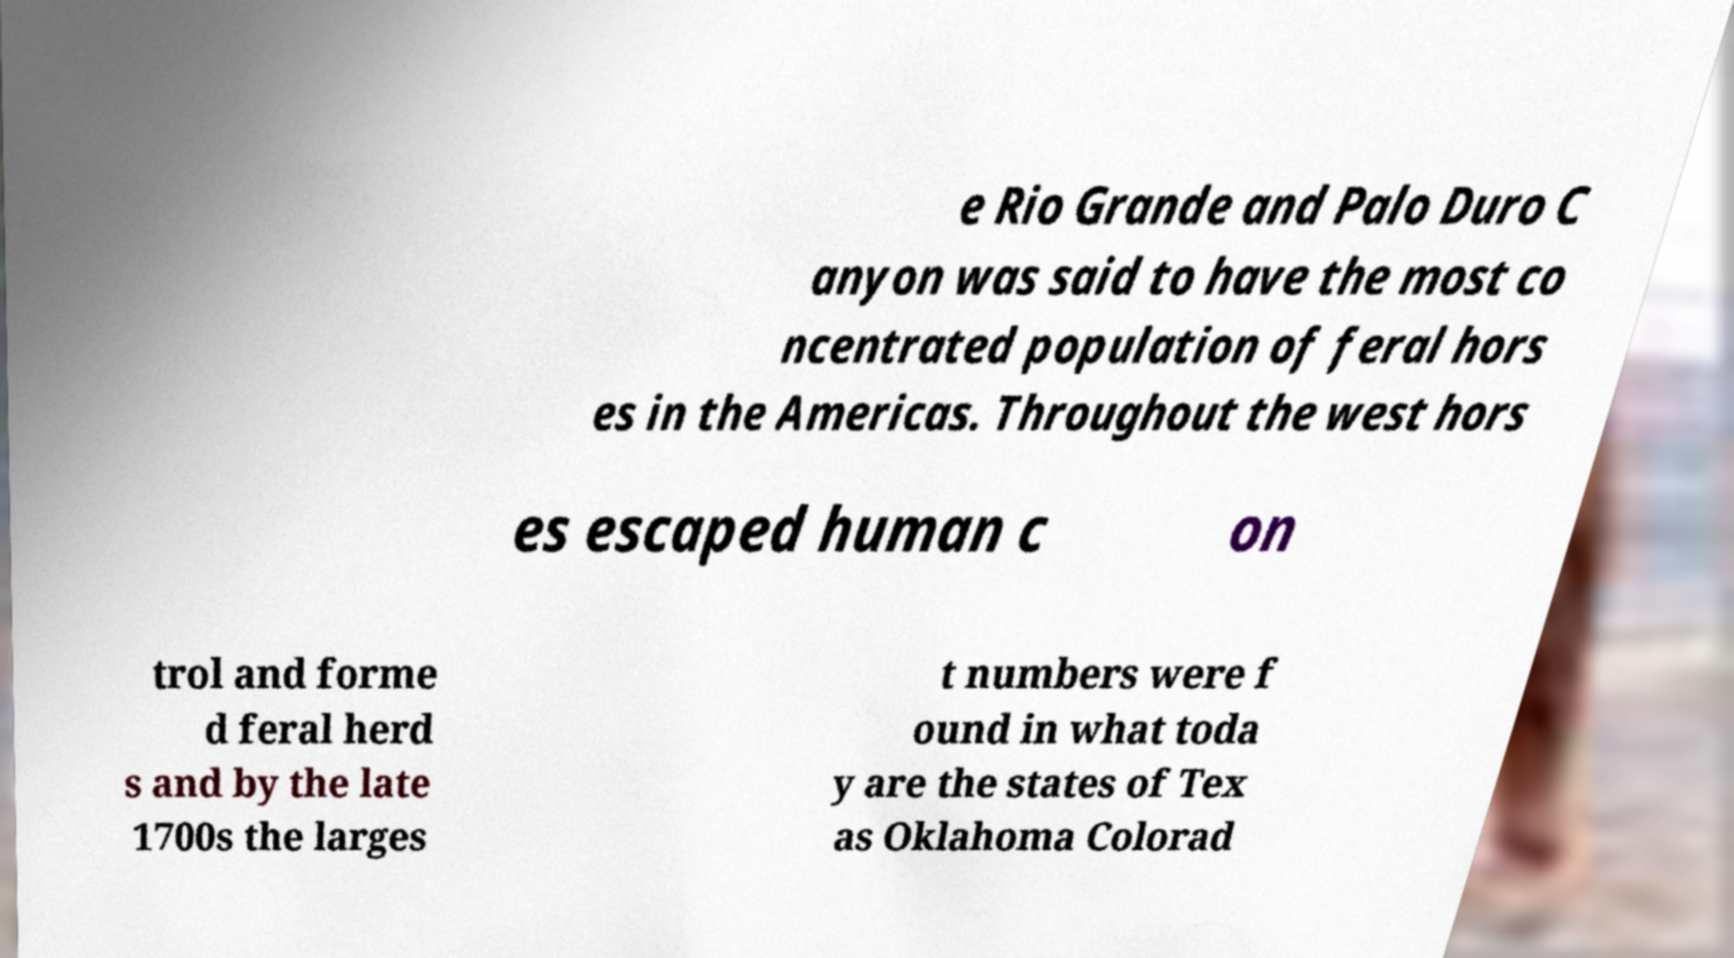I need the written content from this picture converted into text. Can you do that? e Rio Grande and Palo Duro C anyon was said to have the most co ncentrated population of feral hors es in the Americas. Throughout the west hors es escaped human c on trol and forme d feral herd s and by the late 1700s the larges t numbers were f ound in what toda y are the states of Tex as Oklahoma Colorad 